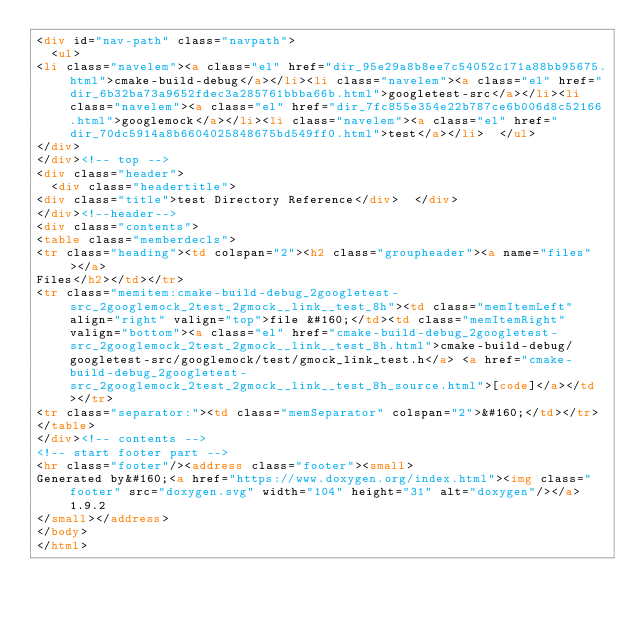<code> <loc_0><loc_0><loc_500><loc_500><_HTML_><div id="nav-path" class="navpath">
  <ul>
<li class="navelem"><a class="el" href="dir_95e29a8b8ee7c54052c171a88bb95675.html">cmake-build-debug</a></li><li class="navelem"><a class="el" href="dir_6b32ba73a9652fdec3a285761bbba66b.html">googletest-src</a></li><li class="navelem"><a class="el" href="dir_7fc855e354e22b787ce6b006d8c52166.html">googlemock</a></li><li class="navelem"><a class="el" href="dir_70dc5914a8b6604025848675bd549ff0.html">test</a></li>  </ul>
</div>
</div><!-- top -->
<div class="header">
  <div class="headertitle">
<div class="title">test Directory Reference</div>  </div>
</div><!--header-->
<div class="contents">
<table class="memberdecls">
<tr class="heading"><td colspan="2"><h2 class="groupheader"><a name="files"></a>
Files</h2></td></tr>
<tr class="memitem:cmake-build-debug_2googletest-src_2googlemock_2test_2gmock__link__test_8h"><td class="memItemLeft" align="right" valign="top">file &#160;</td><td class="memItemRight" valign="bottom"><a class="el" href="cmake-build-debug_2googletest-src_2googlemock_2test_2gmock__link__test_8h.html">cmake-build-debug/googletest-src/googlemock/test/gmock_link_test.h</a> <a href="cmake-build-debug_2googletest-src_2googlemock_2test_2gmock__link__test_8h_source.html">[code]</a></td></tr>
<tr class="separator:"><td class="memSeparator" colspan="2">&#160;</td></tr>
</table>
</div><!-- contents -->
<!-- start footer part -->
<hr class="footer"/><address class="footer"><small>
Generated by&#160;<a href="https://www.doxygen.org/index.html"><img class="footer" src="doxygen.svg" width="104" height="31" alt="doxygen"/></a> 1.9.2
</small></address>
</body>
</html>
</code> 